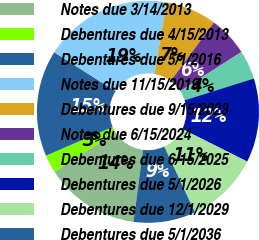Convert chart. <chart><loc_0><loc_0><loc_500><loc_500><pie_chart><fcel>Notes due 3/14/2013<fcel>Debentures due 4/15/2013<fcel>Debentures due 5/1/2016<fcel>Notes due 11/15/2019<fcel>Debentures due 9/15/2023<fcel>Notes due 6/15/2024<fcel>Debentures due 6/15/2025<fcel>Debentures due 5/1/2026<fcel>Debentures due 12/1/2029<fcel>Debentures due 5/1/2036<nl><fcel>13.86%<fcel>2.6%<fcel>15.47%<fcel>18.69%<fcel>7.43%<fcel>5.82%<fcel>4.21%<fcel>12.25%<fcel>10.64%<fcel>9.03%<nl></chart> 